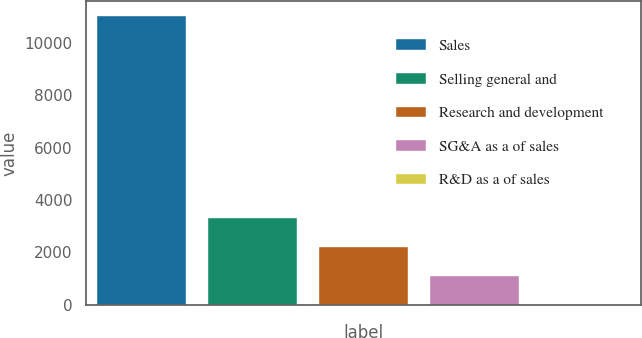Convert chart to OTSL. <chart><loc_0><loc_0><loc_500><loc_500><bar_chart><fcel>Sales<fcel>Selling general and<fcel>Research and development<fcel>SG&A as a of sales<fcel>R&D as a of sales<nl><fcel>11025.9<fcel>3311.62<fcel>2209.58<fcel>1107.54<fcel>5.5<nl></chart> 